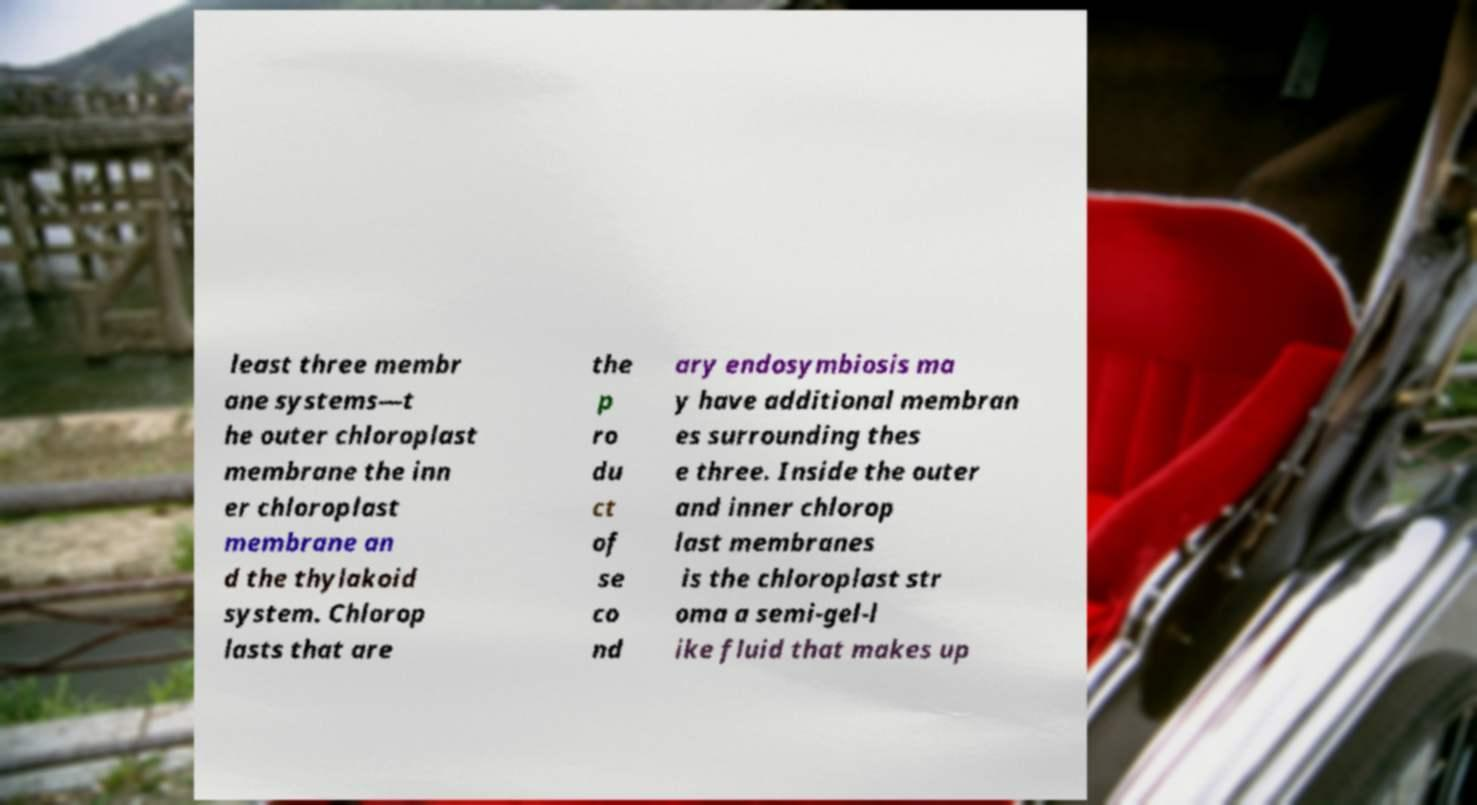Please read and relay the text visible in this image. What does it say? least three membr ane systems—t he outer chloroplast membrane the inn er chloroplast membrane an d the thylakoid system. Chlorop lasts that are the p ro du ct of se co nd ary endosymbiosis ma y have additional membran es surrounding thes e three. Inside the outer and inner chlorop last membranes is the chloroplast str oma a semi-gel-l ike fluid that makes up 